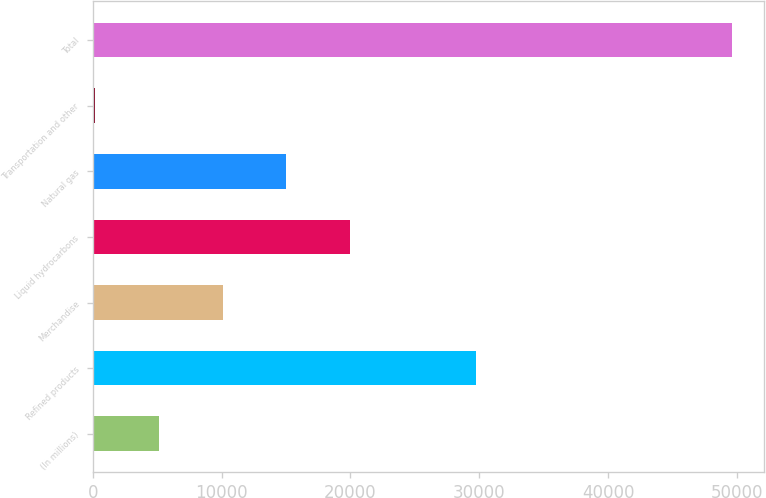Convert chart to OTSL. <chart><loc_0><loc_0><loc_500><loc_500><bar_chart><fcel>(In millions)<fcel>Refined products<fcel>Merchandise<fcel>Liquid hydrocarbons<fcel>Natural gas<fcel>Transportation and other<fcel>Total<nl><fcel>5142.5<fcel>29780<fcel>10082<fcel>19961<fcel>15021.5<fcel>203<fcel>49598<nl></chart> 